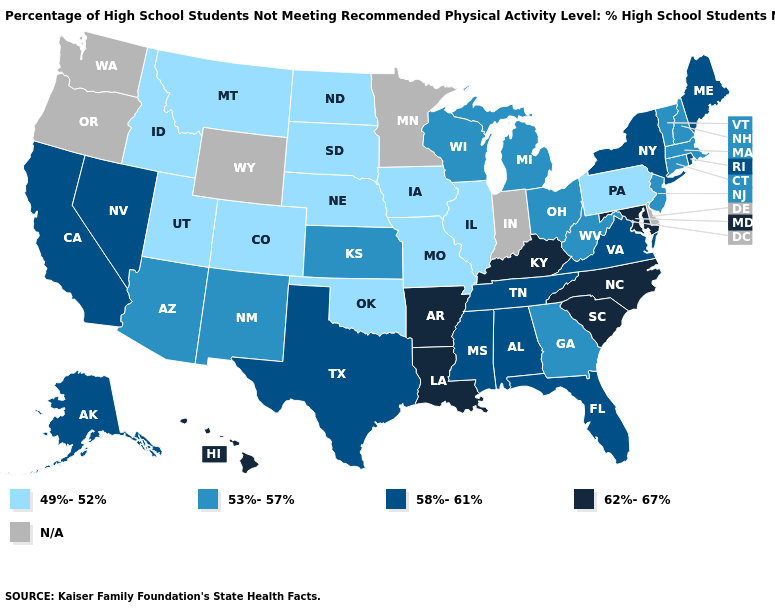What is the value of Indiana?
Give a very brief answer. N/A. What is the value of Maine?
Concise answer only. 58%-61%. Among the states that border California , which have the lowest value?
Concise answer only. Arizona. Name the states that have a value in the range 62%-67%?
Write a very short answer. Arkansas, Hawaii, Kentucky, Louisiana, Maryland, North Carolina, South Carolina. Does the first symbol in the legend represent the smallest category?
Give a very brief answer. Yes. Name the states that have a value in the range 49%-52%?
Quick response, please. Colorado, Idaho, Illinois, Iowa, Missouri, Montana, Nebraska, North Dakota, Oklahoma, Pennsylvania, South Dakota, Utah. Name the states that have a value in the range 49%-52%?
Write a very short answer. Colorado, Idaho, Illinois, Iowa, Missouri, Montana, Nebraska, North Dakota, Oklahoma, Pennsylvania, South Dakota, Utah. What is the highest value in the USA?
Write a very short answer. 62%-67%. What is the lowest value in the Northeast?
Give a very brief answer. 49%-52%. Does the first symbol in the legend represent the smallest category?
Answer briefly. Yes. Which states have the lowest value in the Northeast?
Concise answer only. Pennsylvania. What is the value of Montana?
Concise answer only. 49%-52%. What is the value of New Mexico?
Write a very short answer. 53%-57%. What is the value of Wisconsin?
Quick response, please. 53%-57%. 